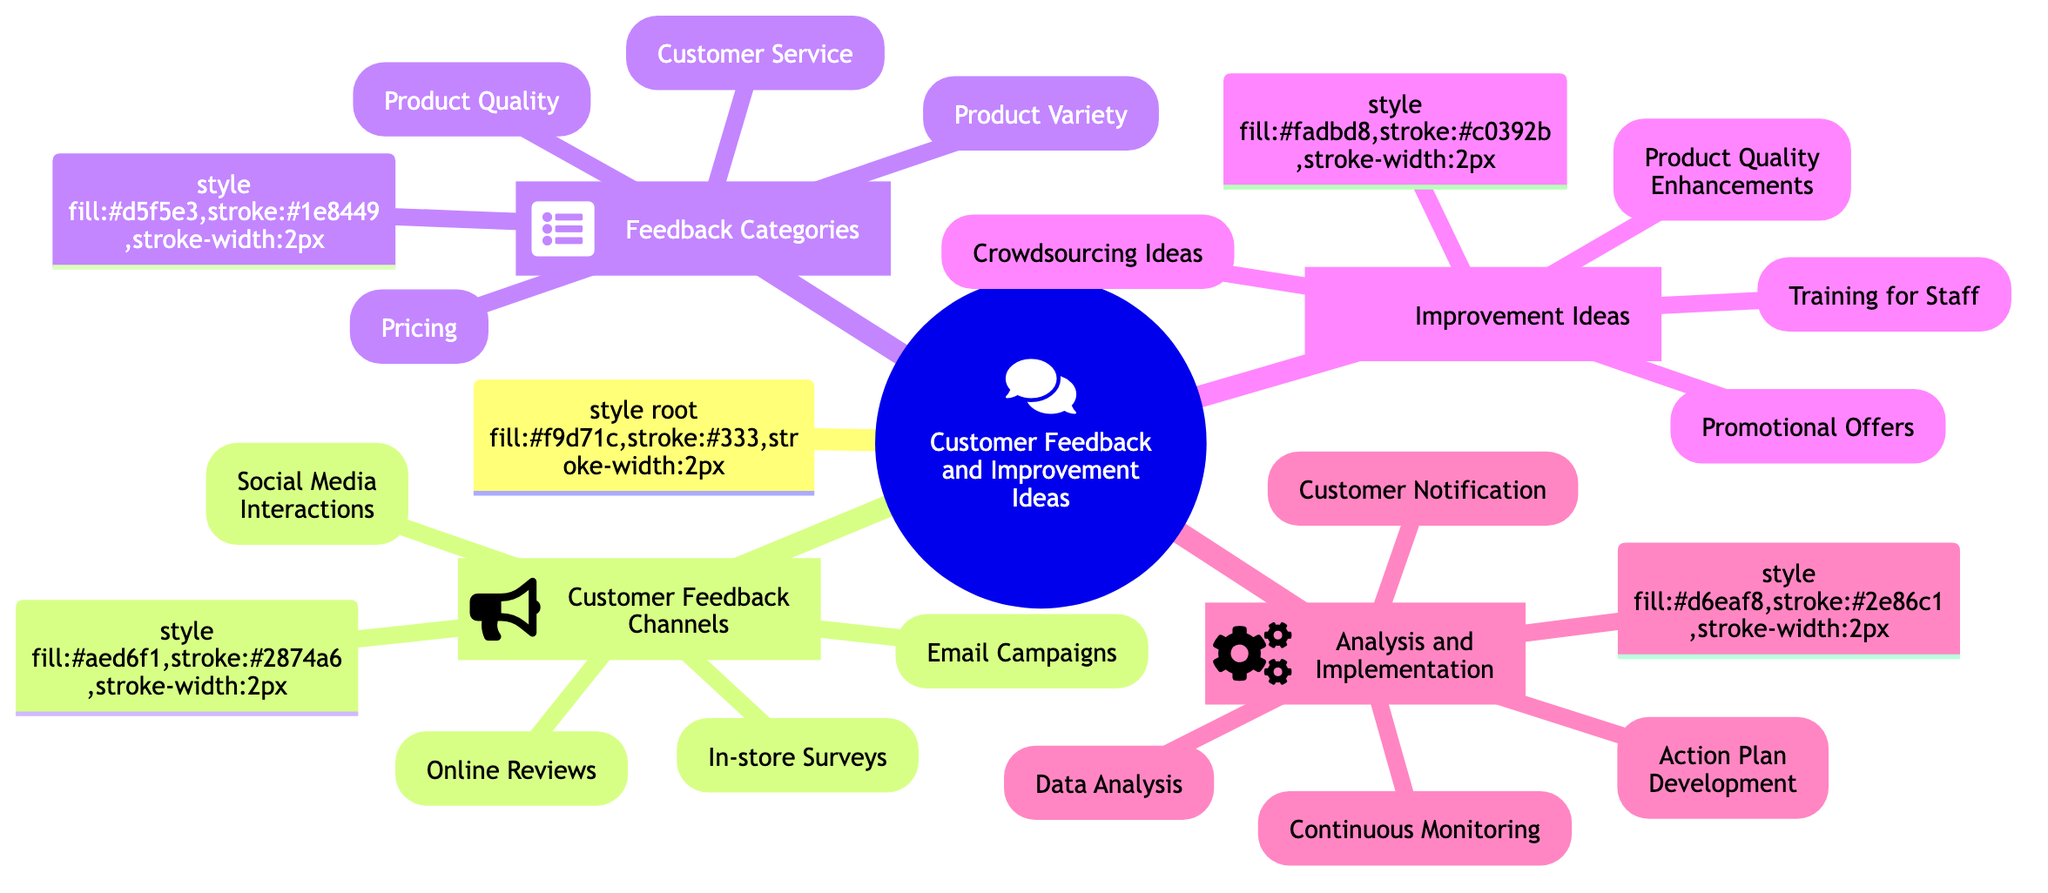What are the feedback categories listed in the diagram? The diagram indicates four feedback categories: Product Quality, Pricing, Customer Service, and Product Variety. This information can be found by examining the "Feedback Categories" section of the mind map.
Answer: Product Quality, Pricing, Customer Service, Product Variety How many customer feedback channels are there? The diagram shows four distinct customer feedback channels: In-store Surveys, Online Reviews, Social Media Interactions, and Email Campaigns. Counting these channels provides the total number.
Answer: 4 What is one idea for improving product quality? The diagram lists "Work with suppliers to ensure high-quality materials" under the "Improvement Ideas" section specifically for product quality enhancements. This is a direct reference to how to improve product quality.
Answer: Work with suppliers to ensure high-quality materials Which method involves customer engagement on social media? The "Social Media Interactions" node under "Customer Feedback Channels" specifically refers to engaging with customers on social platforms. This node clearly points to this feedback method.
Answer: Social Media Interactions What is the purpose of continuous monitoring? The "Continuous Monitoring" section in "Analysis and Implementation" suggests that it is for setting up a schedule for regular feedback reviews and updates. This clearly defines the intent behind continuous monitoring.
Answer: Regular feedback reviews and updates Which improvement idea focuses on customer support? Training for Staff is noted in the "Improvement Ideas" which is directly related to enhancing customer support through regular workshops on best practices. This specifically addresses customer service improvements.
Answer: Training for Staff What feedback channel uses follow-up emails? The diagram specifically identifies "Email Campaigns" as the channel that sends follow-up emails requesting feedback after purchase. This is explicitly stated under customer feedback channels.
Answer: Email Campaigns What kind of analysis tool is mentioned for analyzing feedback data? The "Data Analysis" node lists Google Forms and SurveyMonkey as tools for analyzing feedback data. This is stated in the relevant section pertaining to analysis and implementation.
Answer: Google Forms and SurveyMonkey What type of offers can be introduced to attract customers? The "Promotional Offers" node suggests that introducing seasonal discounts and bundle deals could attract more customers. This idea falls under the improvement ideas focus area.
Answer: Seasonal discounts and bundle deals 